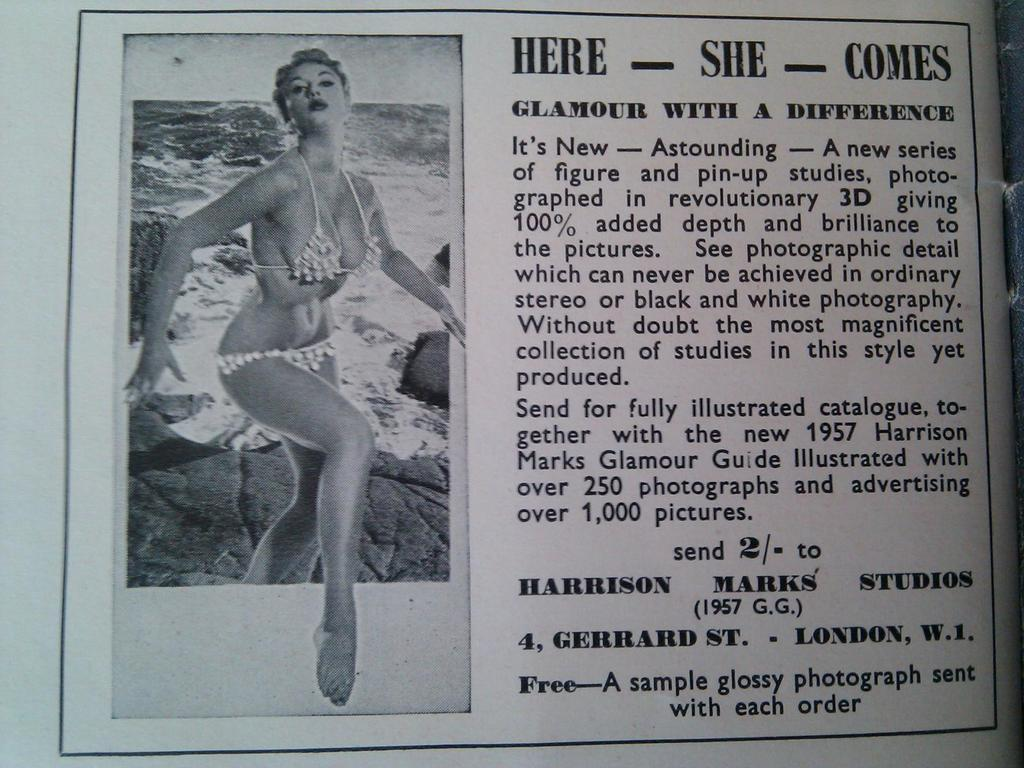What is the main object in the image? There is a paper in the image. What is depicted on the paper? There is a picture of a lady printed on the paper. What else can be seen on the paper besides the picture? There is text visible on the paper. How many friends does the lady in the image need to help her with the slip? There is no mention of friends or a slip in the image, so it is not possible to answer that question. 